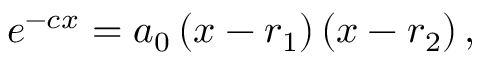Convert formula to latex. <formula><loc_0><loc_0><loc_500><loc_500>e ^ { - c x } = a _ { 0 } \left ( x - r _ { 1 } \right ) \left ( x - r _ { 2 } \right ) ,</formula> 